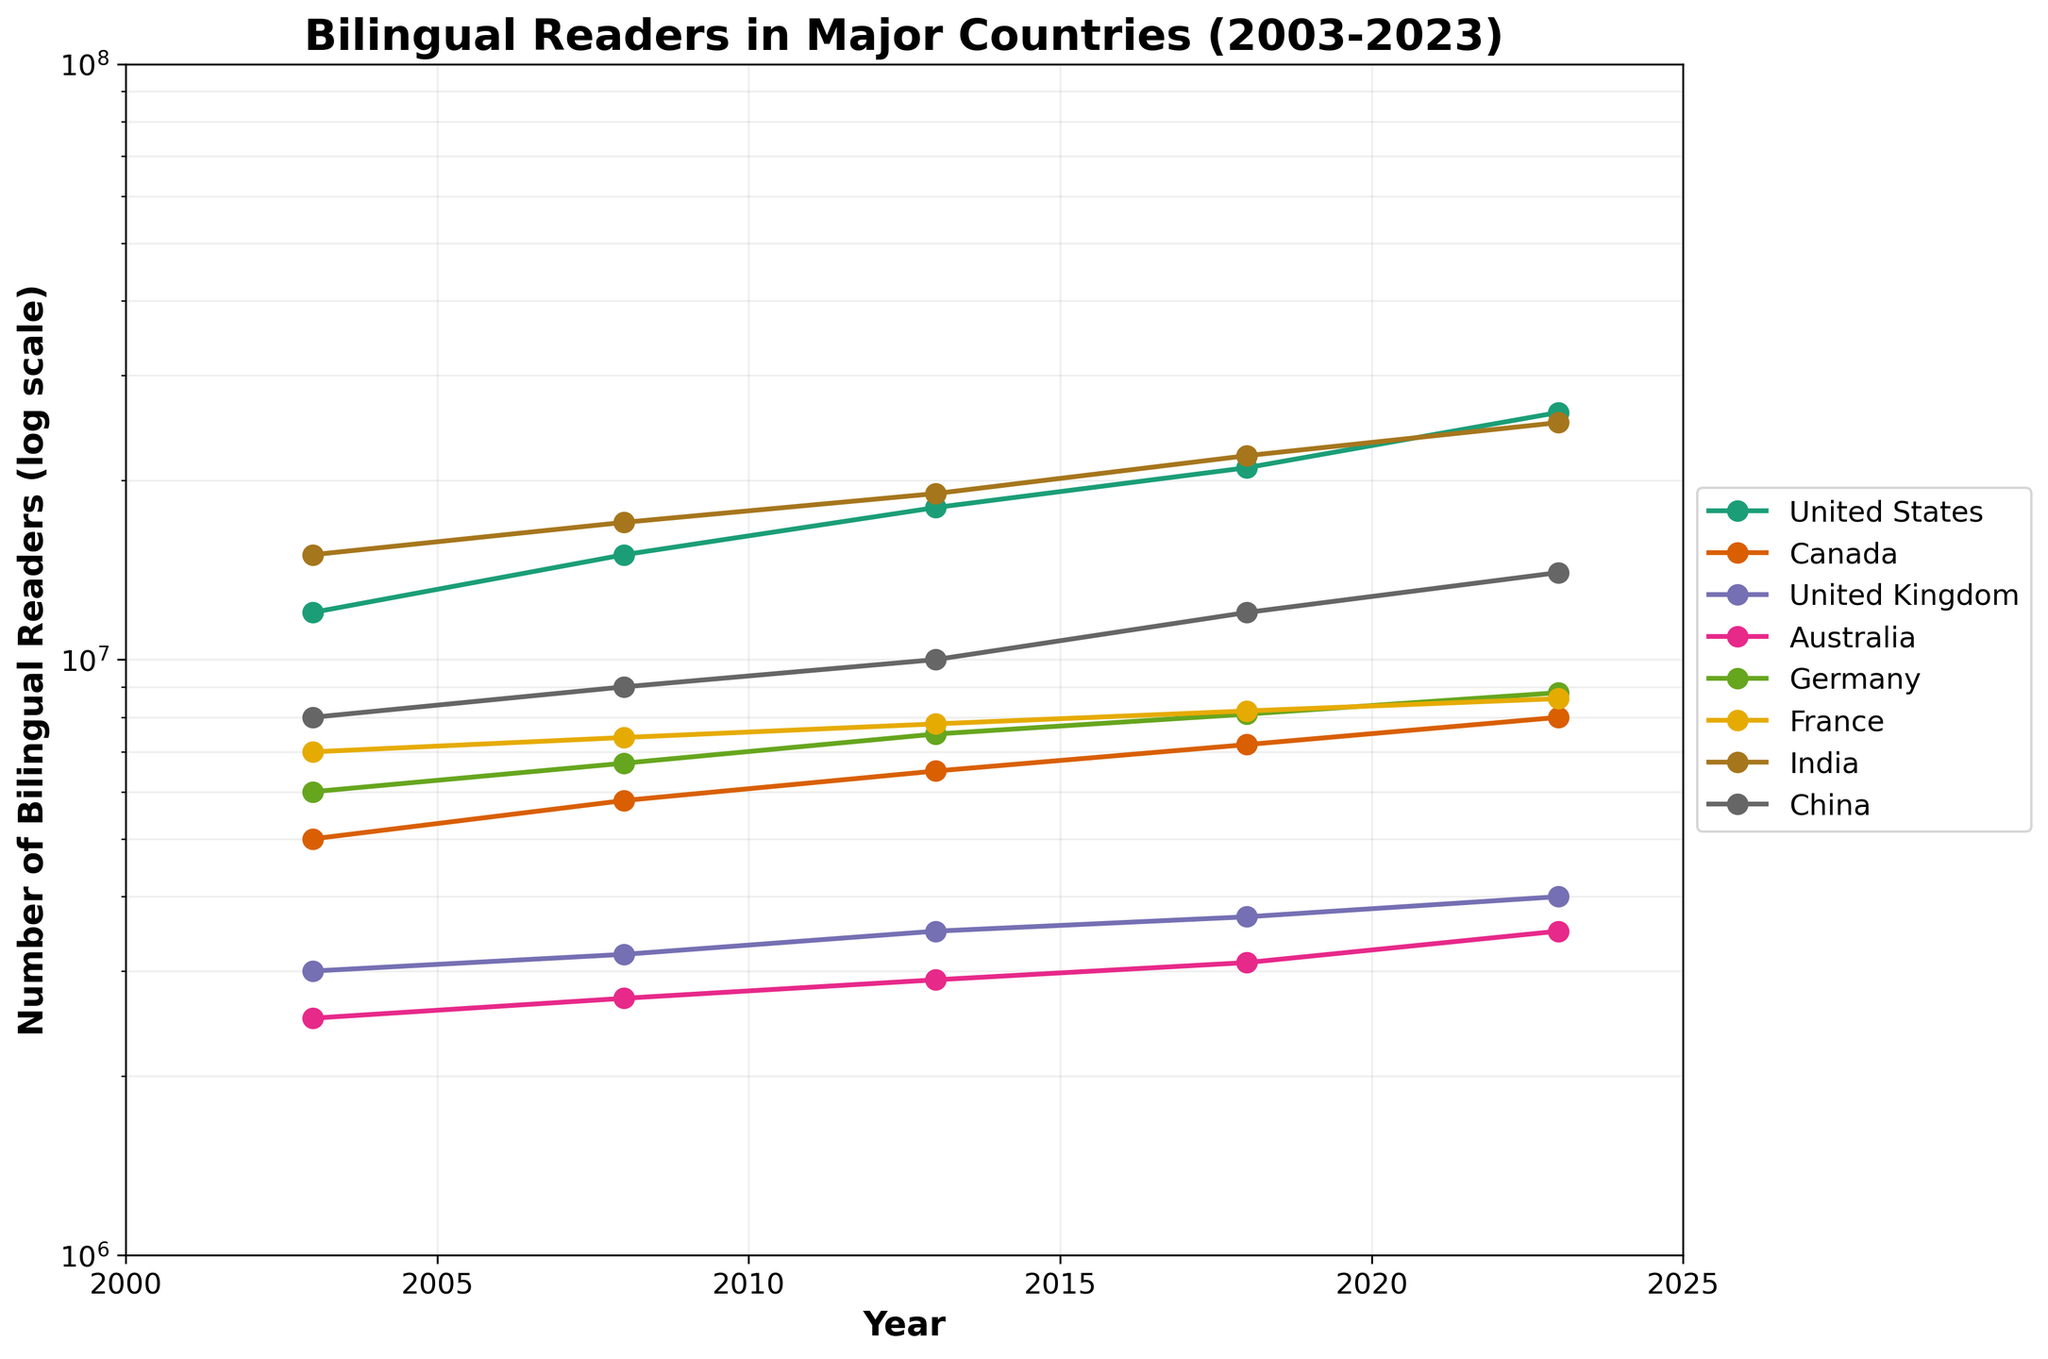what is the title of the figure? The title of the figure is typically displayed at the top and describes what the plot represents. In this case, it reads "Bilingual Readers in Major Countries (2003-2023)"
Answer: Bilingual Readers in Major Countries (2003-2023) How many countries are represented in the plot? Count the number of different countries plotted in the figure. A different color represents each country line.
Answer: 7 What is the highest number of bilingual readers recorded for the United States, and in what year does it occur? Find the highest point on the line representing the United States (typically labeled in the legend) and check the corresponding year on the x-axis.
Answer: 26,000,000 in 2023 Which country shows the smallest increase in the number of bilingual readers over the 20-year period? Calculate the difference in bilingual readers from 2003 to 2023 for each country, and determine which country has the smallest increase.
Answer: United Kingdom What is the common trend observed in the number of bilingual readers in all countries over the past 20 years? Observe the direction of the lines for all countries from 2003 to 2023 and determine if they all show a general trend.
Answer: Increasing What was the number of bilingual readers in India in 2008, and how does it compare to the number of bilingual readers in China in the same year? Locate the points representing India and China for the year 2008 on the plot and compare their values.
Answer: India: 17,000,000, China: 9,000,000. India had more By how much did the number of bilingual readers in Canada change from 2018 to 2023? Locate the points on the line for Canada in 2018 and 2023, then find the difference between these values.
Answer: 800,000 Which country had the most significant percentage increase in the number of bilingual readers from 2003 to 2023? For each country, calculate (2023 value - 2003 value) / 2003 value and find the country with the highest percentage.
Answer: United States How do the trends in bilingual reader growth compare between Germany and France? Analyze the slope and growth patterns of the lines representing Germany and France from 2003 to 2023.
Answer: Germany shows a steeper increase compared to France What does the log scale on the y-axis indicate about the growth rate of the number of bilingual readers in these countries? A log scale helps to visualize exponential growth data more linearly. Therefore, increasing lines on a log scale indicate exponential growth in the number of bilingual readers.
Answer: Exponential growth 